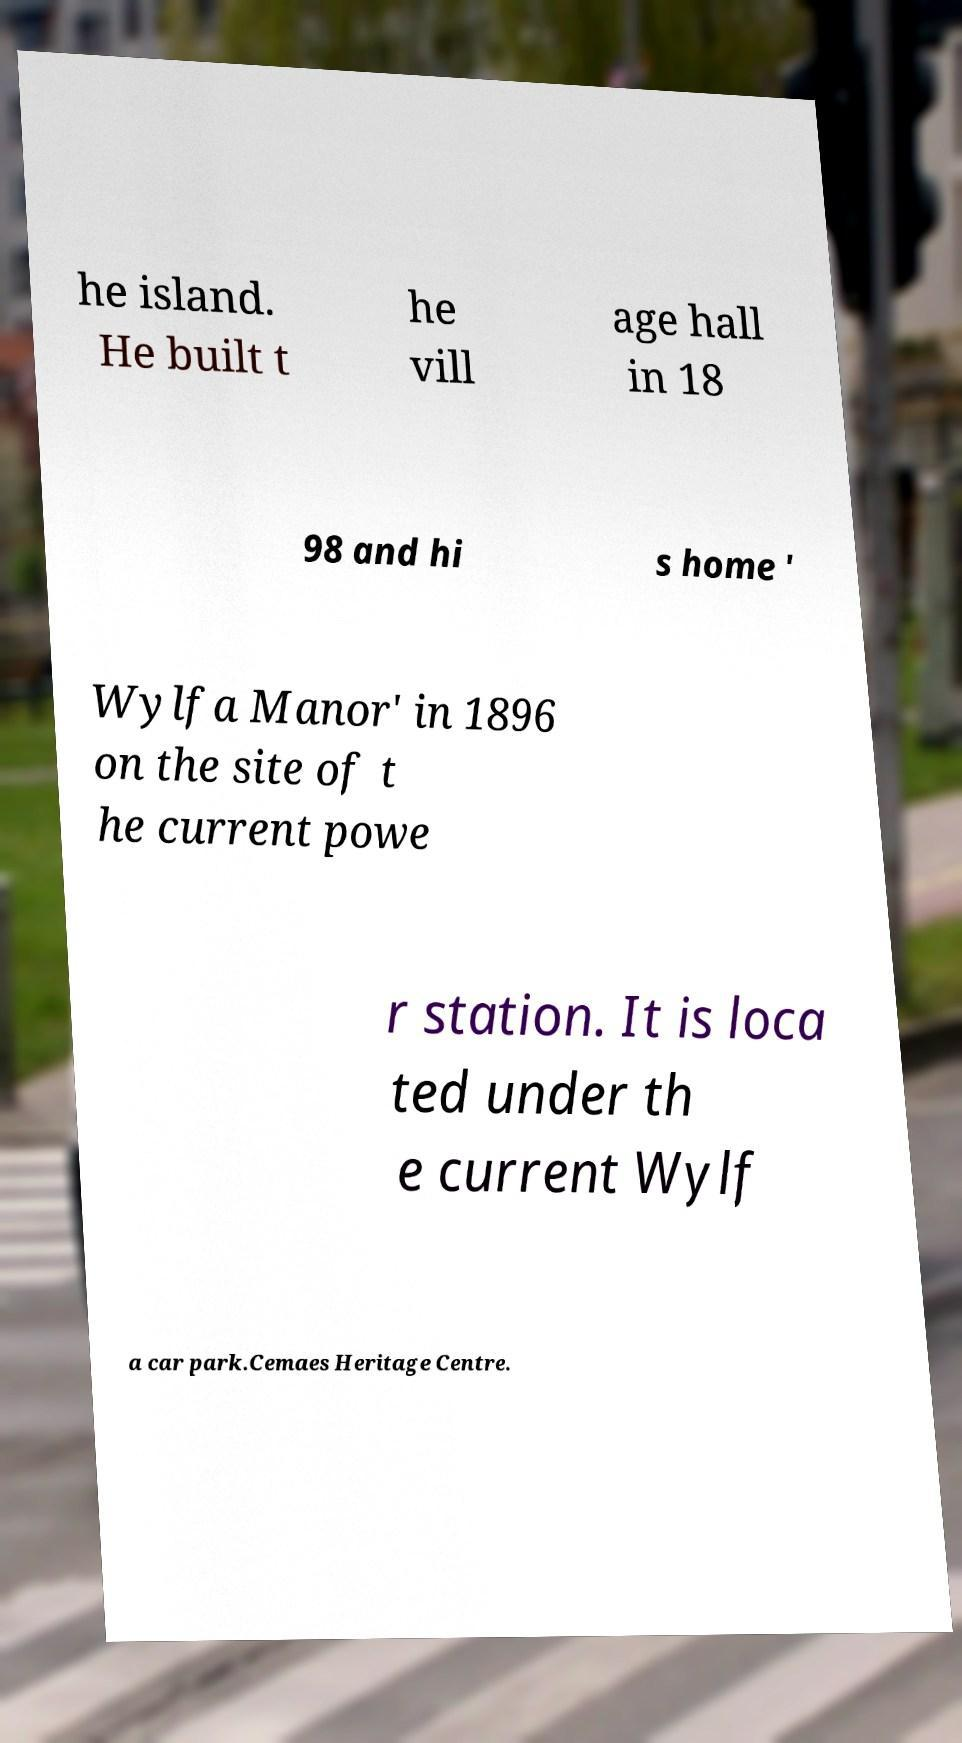Can you read and provide the text displayed in the image?This photo seems to have some interesting text. Can you extract and type it out for me? he island. He built t he vill age hall in 18 98 and hi s home ' Wylfa Manor' in 1896 on the site of t he current powe r station. It is loca ted under th e current Wylf a car park.Cemaes Heritage Centre. 